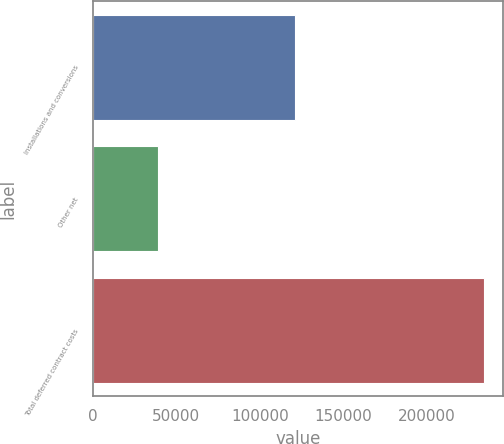Convert chart to OTSL. <chart><loc_0><loc_0><loc_500><loc_500><bar_chart><fcel>Installations and conversions<fcel>Other net<fcel>Total deferred contract costs<nl><fcel>120901<fcel>38815<fcel>233996<nl></chart> 